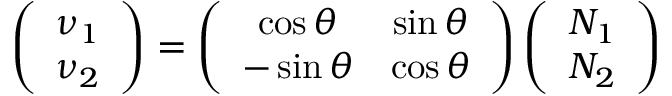<formula> <loc_0><loc_0><loc_500><loc_500>\left ( \begin{array} { c } { { \nu _ { 1 } } } \\ { { \nu _ { 2 } } } \end{array} \right ) = \left ( \begin{array} { c c } { \cos \theta } & { \sin \theta } \\ { - \sin \theta } & { \cos \theta } \end{array} \right ) \left ( \begin{array} { c } { { N _ { 1 } } } \\ { { N _ { 2 } } } \end{array} \right )</formula> 